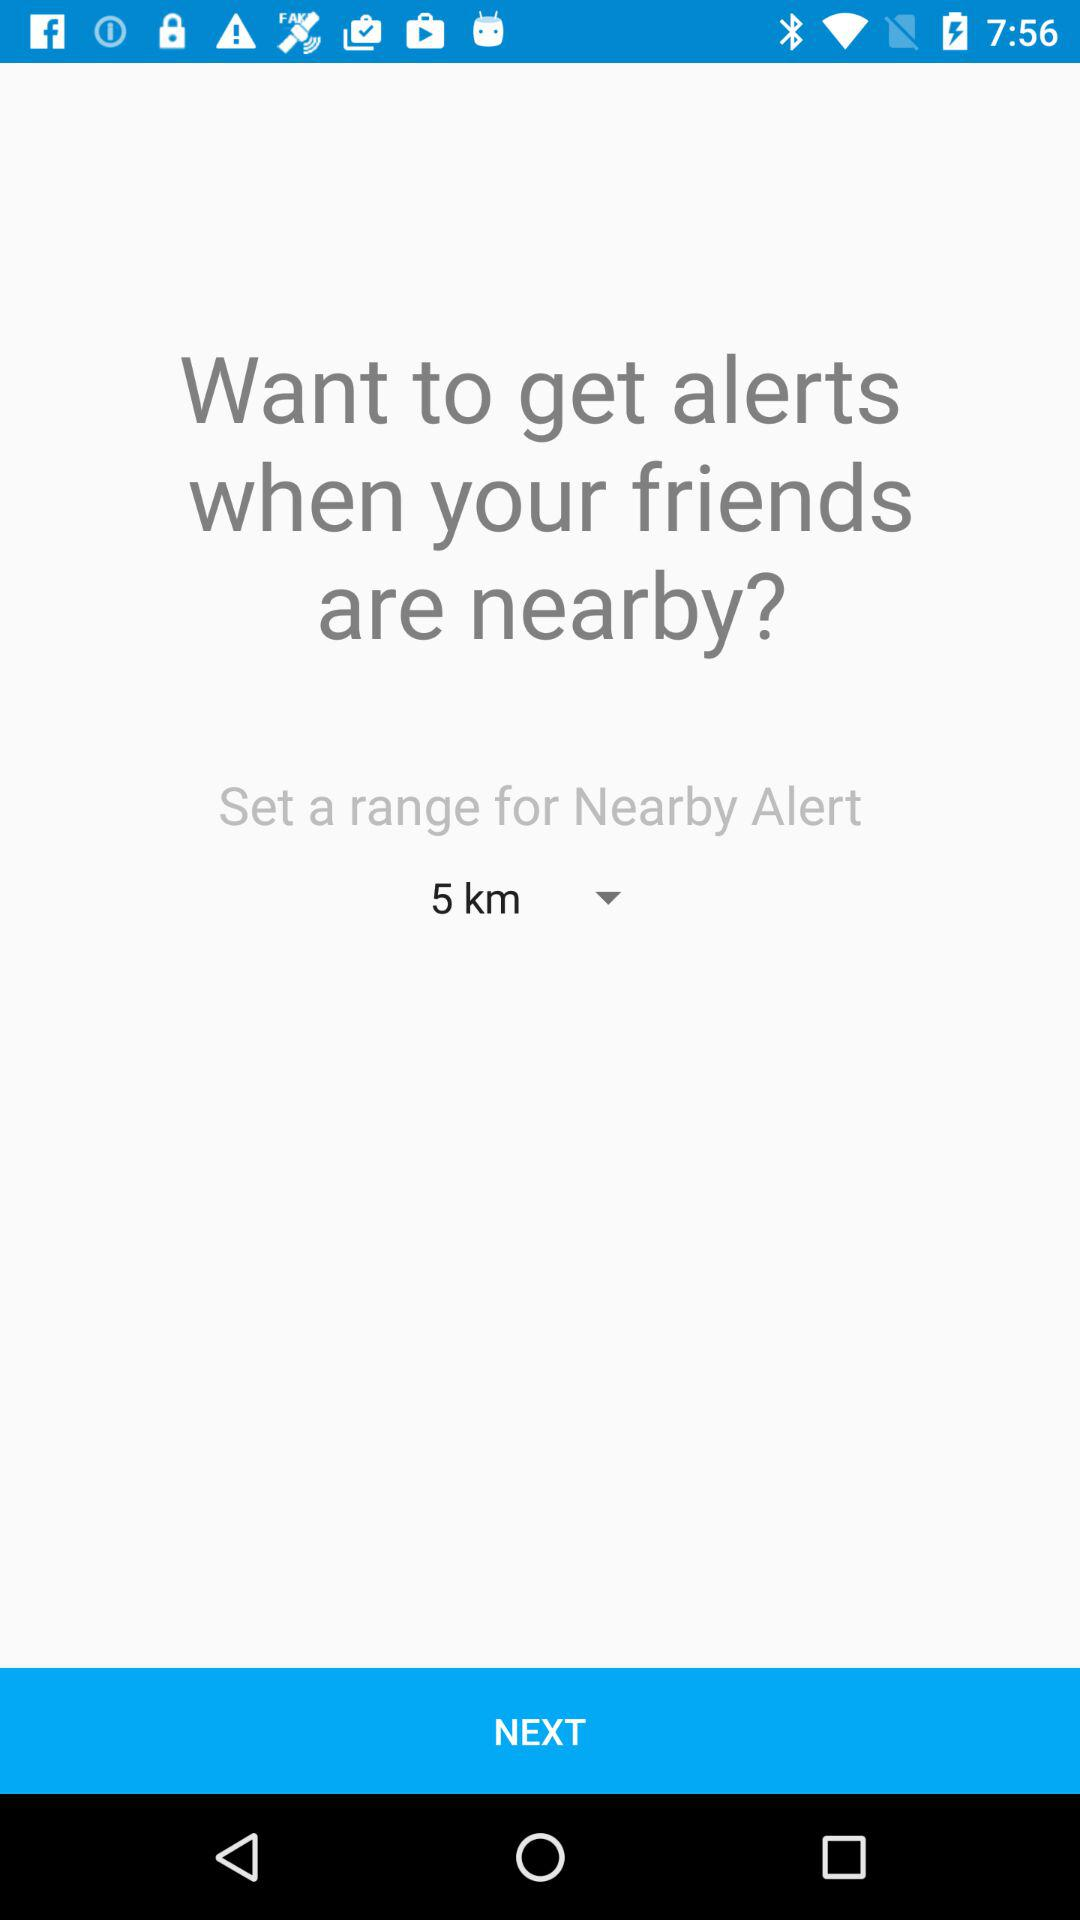What is the distance range for the Nearby Alert?
Answer the question using a single word or phrase. 5 km 